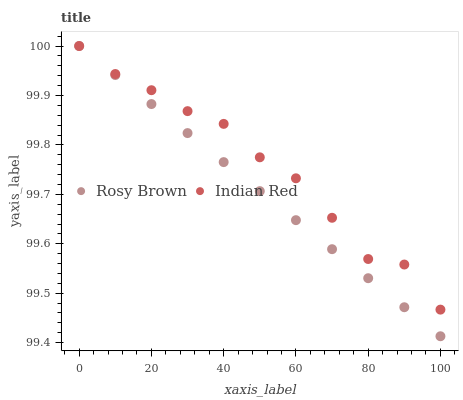Does Rosy Brown have the minimum area under the curve?
Answer yes or no. Yes. Does Indian Red have the maximum area under the curve?
Answer yes or no. Yes. Does Indian Red have the minimum area under the curve?
Answer yes or no. No. Is Rosy Brown the smoothest?
Answer yes or no. Yes. Is Indian Red the roughest?
Answer yes or no. Yes. Is Indian Red the smoothest?
Answer yes or no. No. Does Rosy Brown have the lowest value?
Answer yes or no. Yes. Does Indian Red have the lowest value?
Answer yes or no. No. Does Indian Red have the highest value?
Answer yes or no. Yes. Does Indian Red intersect Rosy Brown?
Answer yes or no. Yes. Is Indian Red less than Rosy Brown?
Answer yes or no. No. Is Indian Red greater than Rosy Brown?
Answer yes or no. No. 